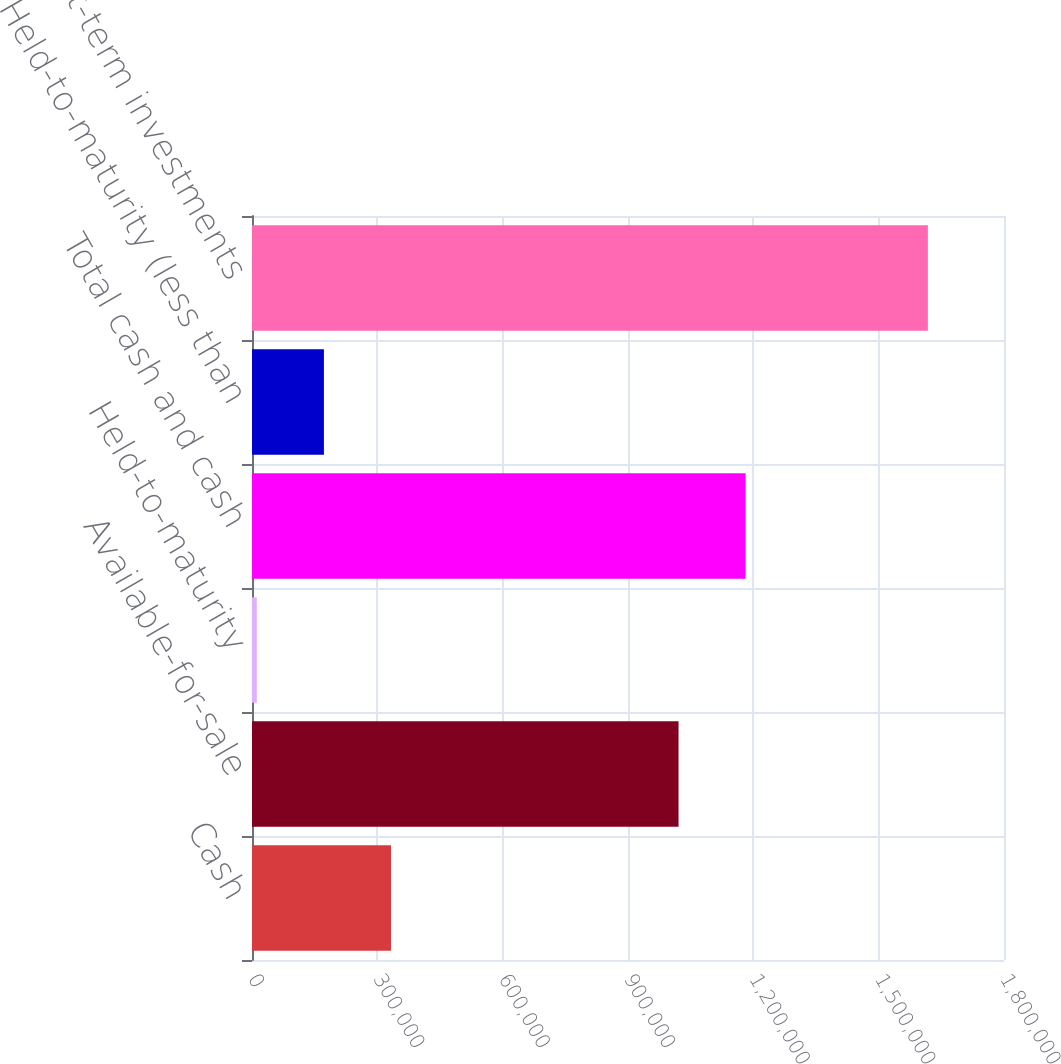Convert chart to OTSL. <chart><loc_0><loc_0><loc_500><loc_500><bar_chart><fcel>Cash<fcel>Available-for-sale<fcel>Held-to-maturity<fcel>Total cash and cash<fcel>Held-to-maturity (less than<fcel>Total short-term investments<nl><fcel>332791<fcel>1.02099e+06<fcel>11547<fcel>1.18162e+06<fcel>172169<fcel>1.61777e+06<nl></chart> 